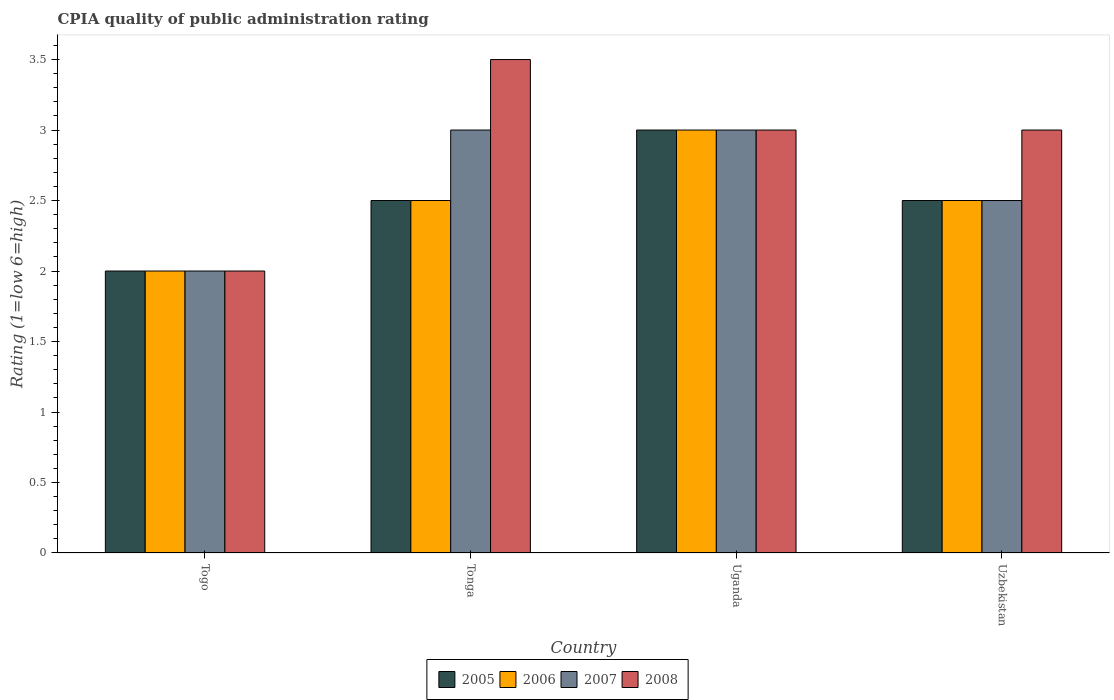How many bars are there on the 1st tick from the left?
Ensure brevity in your answer.  4. How many bars are there on the 1st tick from the right?
Provide a succinct answer. 4. What is the label of the 1st group of bars from the left?
Provide a short and direct response. Togo. In how many cases, is the number of bars for a given country not equal to the number of legend labels?
Your answer should be very brief. 0. In which country was the CPIA rating in 2007 maximum?
Provide a short and direct response. Tonga. In which country was the CPIA rating in 2007 minimum?
Offer a very short reply. Togo. What is the total CPIA rating in 2008 in the graph?
Provide a succinct answer. 11.5. What is the difference between the CPIA rating in 2005 in Togo and that in Tonga?
Your answer should be compact. -0.5. What is the difference between the CPIA rating in 2006 in Uzbekistan and the CPIA rating in 2007 in Uganda?
Keep it short and to the point. -0.5. What is the ratio of the CPIA rating in 2007 in Togo to that in Uganda?
Provide a succinct answer. 0.67. What is the difference between the highest and the second highest CPIA rating in 2008?
Offer a very short reply. -0.5. In how many countries, is the CPIA rating in 2005 greater than the average CPIA rating in 2005 taken over all countries?
Keep it short and to the point. 1. Is the sum of the CPIA rating in 2006 in Tonga and Uganda greater than the maximum CPIA rating in 2007 across all countries?
Your answer should be compact. Yes. Is it the case that in every country, the sum of the CPIA rating in 2007 and CPIA rating in 2005 is greater than the sum of CPIA rating in 2008 and CPIA rating in 2006?
Offer a terse response. No. What does the 4th bar from the right in Uzbekistan represents?
Provide a succinct answer. 2005. Is it the case that in every country, the sum of the CPIA rating in 2006 and CPIA rating in 2008 is greater than the CPIA rating in 2005?
Your answer should be compact. Yes. Are all the bars in the graph horizontal?
Your answer should be compact. No. How are the legend labels stacked?
Provide a succinct answer. Horizontal. What is the title of the graph?
Provide a succinct answer. CPIA quality of public administration rating. What is the label or title of the Y-axis?
Make the answer very short. Rating (1=low 6=high). What is the Rating (1=low 6=high) in 2005 in Togo?
Offer a terse response. 2. What is the Rating (1=low 6=high) in 2006 in Togo?
Give a very brief answer. 2. What is the Rating (1=low 6=high) of 2006 in Tonga?
Your response must be concise. 2.5. What is the Rating (1=low 6=high) in 2007 in Tonga?
Your response must be concise. 3. What is the Rating (1=low 6=high) in 2008 in Tonga?
Your response must be concise. 3.5. What is the Rating (1=low 6=high) of 2006 in Uganda?
Your response must be concise. 3. What is the Rating (1=low 6=high) in 2008 in Uganda?
Your answer should be compact. 3. What is the Rating (1=low 6=high) in 2006 in Uzbekistan?
Keep it short and to the point. 2.5. Across all countries, what is the maximum Rating (1=low 6=high) of 2005?
Your response must be concise. 3. Across all countries, what is the maximum Rating (1=low 6=high) in 2006?
Make the answer very short. 3. Across all countries, what is the maximum Rating (1=low 6=high) of 2007?
Your answer should be compact. 3. Across all countries, what is the maximum Rating (1=low 6=high) in 2008?
Ensure brevity in your answer.  3.5. Across all countries, what is the minimum Rating (1=low 6=high) of 2007?
Offer a very short reply. 2. Across all countries, what is the minimum Rating (1=low 6=high) of 2008?
Make the answer very short. 2. What is the total Rating (1=low 6=high) of 2005 in the graph?
Offer a terse response. 10. What is the total Rating (1=low 6=high) in 2006 in the graph?
Keep it short and to the point. 10. What is the total Rating (1=low 6=high) in 2007 in the graph?
Make the answer very short. 10.5. What is the difference between the Rating (1=low 6=high) of 2006 in Togo and that in Tonga?
Your response must be concise. -0.5. What is the difference between the Rating (1=low 6=high) of 2006 in Togo and that in Uganda?
Your answer should be compact. -1. What is the difference between the Rating (1=low 6=high) in 2008 in Togo and that in Uganda?
Provide a short and direct response. -1. What is the difference between the Rating (1=low 6=high) in 2005 in Togo and that in Uzbekistan?
Provide a succinct answer. -0.5. What is the difference between the Rating (1=low 6=high) of 2006 in Togo and that in Uzbekistan?
Your response must be concise. -0.5. What is the difference between the Rating (1=low 6=high) in 2007 in Togo and that in Uzbekistan?
Provide a short and direct response. -0.5. What is the difference between the Rating (1=low 6=high) in 2006 in Tonga and that in Uganda?
Ensure brevity in your answer.  -0.5. What is the difference between the Rating (1=low 6=high) of 2007 in Tonga and that in Uganda?
Your response must be concise. 0. What is the difference between the Rating (1=low 6=high) in 2005 in Tonga and that in Uzbekistan?
Keep it short and to the point. 0. What is the difference between the Rating (1=low 6=high) in 2006 in Tonga and that in Uzbekistan?
Offer a terse response. 0. What is the difference between the Rating (1=low 6=high) of 2007 in Tonga and that in Uzbekistan?
Your response must be concise. 0.5. What is the difference between the Rating (1=low 6=high) in 2005 in Uganda and that in Uzbekistan?
Offer a terse response. 0.5. What is the difference between the Rating (1=low 6=high) of 2006 in Uganda and that in Uzbekistan?
Offer a very short reply. 0.5. What is the difference between the Rating (1=low 6=high) of 2007 in Uganda and that in Uzbekistan?
Provide a short and direct response. 0.5. What is the difference between the Rating (1=low 6=high) of 2005 in Togo and the Rating (1=low 6=high) of 2008 in Tonga?
Offer a very short reply. -1.5. What is the difference between the Rating (1=low 6=high) of 2006 in Togo and the Rating (1=low 6=high) of 2007 in Tonga?
Your answer should be compact. -1. What is the difference between the Rating (1=low 6=high) of 2006 in Togo and the Rating (1=low 6=high) of 2008 in Tonga?
Your response must be concise. -1.5. What is the difference between the Rating (1=low 6=high) of 2007 in Togo and the Rating (1=low 6=high) of 2008 in Tonga?
Make the answer very short. -1.5. What is the difference between the Rating (1=low 6=high) of 2005 in Togo and the Rating (1=low 6=high) of 2006 in Uganda?
Keep it short and to the point. -1. What is the difference between the Rating (1=low 6=high) of 2005 in Togo and the Rating (1=low 6=high) of 2007 in Uganda?
Offer a terse response. -1. What is the difference between the Rating (1=low 6=high) in 2006 in Togo and the Rating (1=low 6=high) in 2007 in Uganda?
Keep it short and to the point. -1. What is the difference between the Rating (1=low 6=high) in 2007 in Togo and the Rating (1=low 6=high) in 2008 in Uganda?
Offer a very short reply. -1. What is the difference between the Rating (1=low 6=high) of 2005 in Togo and the Rating (1=low 6=high) of 2007 in Uzbekistan?
Keep it short and to the point. -0.5. What is the difference between the Rating (1=low 6=high) of 2005 in Togo and the Rating (1=low 6=high) of 2008 in Uzbekistan?
Keep it short and to the point. -1. What is the difference between the Rating (1=low 6=high) in 2006 in Togo and the Rating (1=low 6=high) in 2007 in Uzbekistan?
Your response must be concise. -0.5. What is the difference between the Rating (1=low 6=high) of 2005 in Tonga and the Rating (1=low 6=high) of 2006 in Uganda?
Give a very brief answer. -0.5. What is the difference between the Rating (1=low 6=high) of 2005 in Tonga and the Rating (1=low 6=high) of 2007 in Uganda?
Provide a succinct answer. -0.5. What is the difference between the Rating (1=low 6=high) in 2005 in Tonga and the Rating (1=low 6=high) in 2008 in Uganda?
Give a very brief answer. -0.5. What is the difference between the Rating (1=low 6=high) of 2007 in Tonga and the Rating (1=low 6=high) of 2008 in Uganda?
Give a very brief answer. 0. What is the difference between the Rating (1=low 6=high) of 2005 in Tonga and the Rating (1=low 6=high) of 2006 in Uzbekistan?
Offer a very short reply. 0. What is the difference between the Rating (1=low 6=high) of 2005 in Tonga and the Rating (1=low 6=high) of 2007 in Uzbekistan?
Provide a succinct answer. 0. What is the difference between the Rating (1=low 6=high) of 2005 in Tonga and the Rating (1=low 6=high) of 2008 in Uzbekistan?
Provide a short and direct response. -0.5. What is the difference between the Rating (1=low 6=high) of 2007 in Tonga and the Rating (1=low 6=high) of 2008 in Uzbekistan?
Make the answer very short. 0. What is the difference between the Rating (1=low 6=high) in 2006 in Uganda and the Rating (1=low 6=high) in 2007 in Uzbekistan?
Make the answer very short. 0.5. What is the difference between the Rating (1=low 6=high) in 2007 in Uganda and the Rating (1=low 6=high) in 2008 in Uzbekistan?
Your answer should be very brief. 0. What is the average Rating (1=low 6=high) in 2005 per country?
Keep it short and to the point. 2.5. What is the average Rating (1=low 6=high) in 2006 per country?
Keep it short and to the point. 2.5. What is the average Rating (1=low 6=high) of 2007 per country?
Offer a very short reply. 2.62. What is the average Rating (1=low 6=high) of 2008 per country?
Your answer should be compact. 2.88. What is the difference between the Rating (1=low 6=high) in 2006 and Rating (1=low 6=high) in 2008 in Togo?
Keep it short and to the point. 0. What is the difference between the Rating (1=low 6=high) in 2005 and Rating (1=low 6=high) in 2006 in Tonga?
Make the answer very short. 0. What is the difference between the Rating (1=low 6=high) in 2005 and Rating (1=low 6=high) in 2007 in Tonga?
Provide a succinct answer. -0.5. What is the difference between the Rating (1=low 6=high) in 2006 and Rating (1=low 6=high) in 2007 in Tonga?
Offer a very short reply. -0.5. What is the difference between the Rating (1=low 6=high) of 2007 and Rating (1=low 6=high) of 2008 in Tonga?
Give a very brief answer. -0.5. What is the difference between the Rating (1=low 6=high) of 2005 and Rating (1=low 6=high) of 2006 in Uganda?
Your answer should be very brief. 0. What is the difference between the Rating (1=low 6=high) in 2005 and Rating (1=low 6=high) in 2007 in Uganda?
Offer a terse response. 0. What is the difference between the Rating (1=low 6=high) of 2006 and Rating (1=low 6=high) of 2007 in Uganda?
Offer a terse response. 0. What is the difference between the Rating (1=low 6=high) in 2006 and Rating (1=low 6=high) in 2008 in Uganda?
Your answer should be very brief. 0. What is the difference between the Rating (1=low 6=high) in 2007 and Rating (1=low 6=high) in 2008 in Uganda?
Offer a terse response. 0. What is the difference between the Rating (1=low 6=high) in 2005 and Rating (1=low 6=high) in 2007 in Uzbekistan?
Give a very brief answer. 0. What is the difference between the Rating (1=low 6=high) of 2005 and Rating (1=low 6=high) of 2008 in Uzbekistan?
Offer a very short reply. -0.5. What is the difference between the Rating (1=low 6=high) of 2006 and Rating (1=low 6=high) of 2008 in Uzbekistan?
Offer a terse response. -0.5. What is the ratio of the Rating (1=low 6=high) of 2005 in Togo to that in Tonga?
Your answer should be very brief. 0.8. What is the ratio of the Rating (1=low 6=high) in 2008 in Togo to that in Tonga?
Keep it short and to the point. 0.57. What is the ratio of the Rating (1=low 6=high) in 2005 in Togo to that in Uganda?
Offer a terse response. 0.67. What is the ratio of the Rating (1=low 6=high) in 2005 in Togo to that in Uzbekistan?
Offer a terse response. 0.8. What is the ratio of the Rating (1=low 6=high) in 2006 in Togo to that in Uzbekistan?
Your answer should be compact. 0.8. What is the ratio of the Rating (1=low 6=high) of 2008 in Togo to that in Uzbekistan?
Ensure brevity in your answer.  0.67. What is the ratio of the Rating (1=low 6=high) of 2005 in Tonga to that in Uganda?
Your response must be concise. 0.83. What is the ratio of the Rating (1=low 6=high) in 2005 in Tonga to that in Uzbekistan?
Provide a short and direct response. 1. What is the ratio of the Rating (1=low 6=high) in 2005 in Uganda to that in Uzbekistan?
Your answer should be compact. 1.2. What is the ratio of the Rating (1=low 6=high) in 2008 in Uganda to that in Uzbekistan?
Offer a terse response. 1. What is the difference between the highest and the second highest Rating (1=low 6=high) of 2007?
Make the answer very short. 0. What is the difference between the highest and the second highest Rating (1=low 6=high) in 2008?
Keep it short and to the point. 0.5. What is the difference between the highest and the lowest Rating (1=low 6=high) in 2005?
Your answer should be very brief. 1. What is the difference between the highest and the lowest Rating (1=low 6=high) in 2006?
Offer a very short reply. 1. 